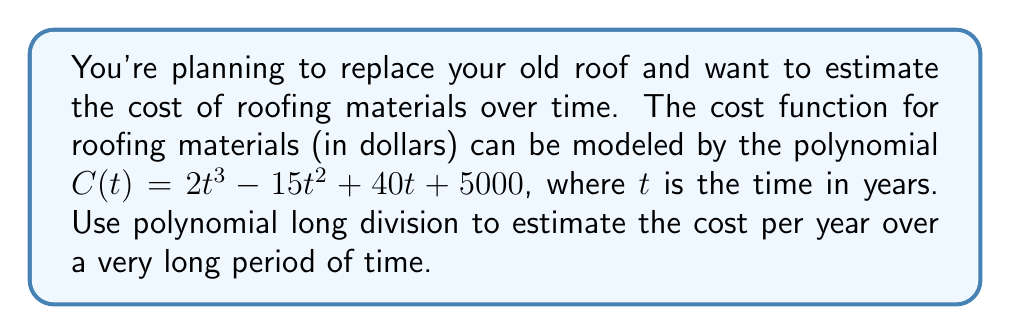Give your solution to this math problem. To estimate the cost per year over a very long period of time, we need to perform polynomial long division of $C(t)$ by $t$. This will give us a quotient that represents the long-term behavior of the function as $t$ approaches infinity.

Let's divide $C(t) = 2t^3 - 15t^2 + 40t + 5000$ by $t$:

$$\begin{array}{r}
2t^2 - 15t + 40 \\
t\enclose{longdiv}{2t^3 - 15t^2 + 40t + 5000} \\
\underline{2t^3 \phantom{- 15t^2 + 40t + 5000}} \\
-15t^2 + 40t + 5000 \\
\underline{-15t^2 \phantom{+ 40t + 5000}} \\
40t + 5000 \\
\underline{40t \phantom{+ 5000}} \\
5000
\end{array}$$

The quotient is $2t^2 - 15t + 40$ with a remainder of $5000$.

This means we can write $C(t)$ as:

$$C(t) = t(2t^2 - 15t + 40) + 5000$$

As $t$ becomes very large, the term $5000/t$ approaches 0, so the long-term behavior is dominated by the quotient $2t^2 - 15t + 40$.

The leading term of this quotient is $2t^2$, which means that over a very long period, the cost will grow quadratically with time, at a rate of approximately $2t^2$ dollars per year.
Answer: $2t^2$ dollars per year 